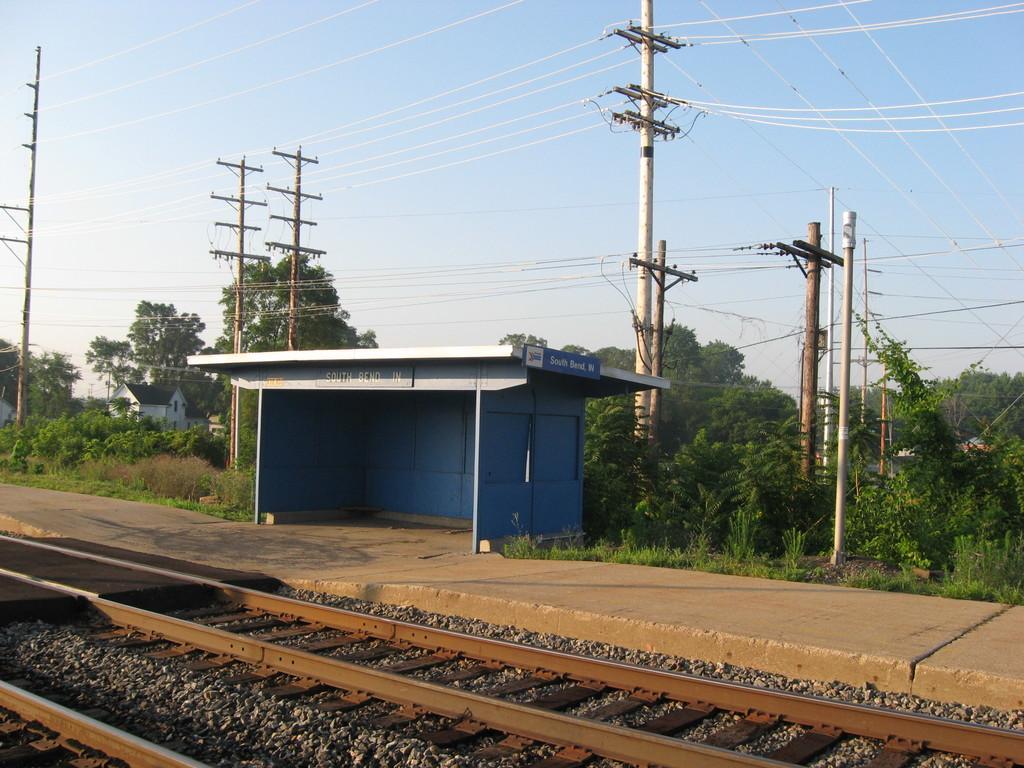Please provide a concise description of this image. In this picture I can observe a railway station. There are railway tracks. I can observe some poles and wires. There are trees in this picture. In the background there is a sky. 